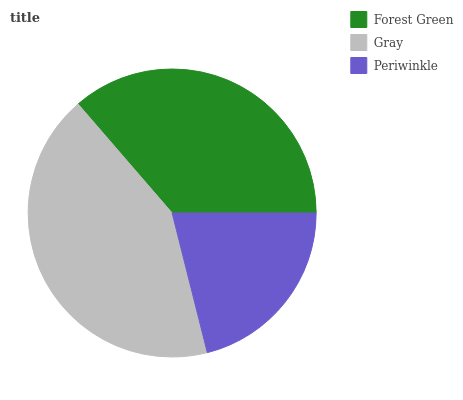Is Periwinkle the minimum?
Answer yes or no. Yes. Is Gray the maximum?
Answer yes or no. Yes. Is Gray the minimum?
Answer yes or no. No. Is Periwinkle the maximum?
Answer yes or no. No. Is Gray greater than Periwinkle?
Answer yes or no. Yes. Is Periwinkle less than Gray?
Answer yes or no. Yes. Is Periwinkle greater than Gray?
Answer yes or no. No. Is Gray less than Periwinkle?
Answer yes or no. No. Is Forest Green the high median?
Answer yes or no. Yes. Is Forest Green the low median?
Answer yes or no. Yes. Is Periwinkle the high median?
Answer yes or no. No. Is Gray the low median?
Answer yes or no. No. 